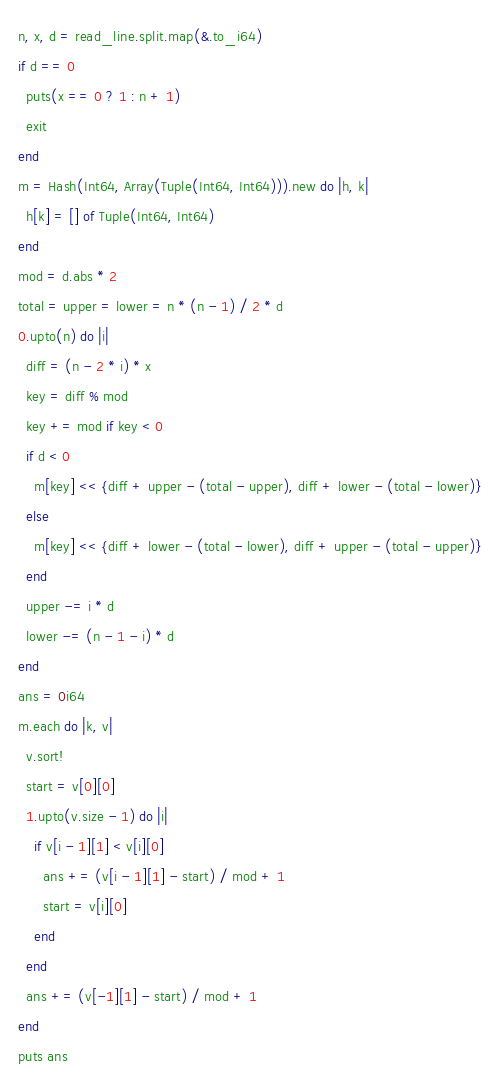<code> <loc_0><loc_0><loc_500><loc_500><_Crystal_>n, x, d = read_line.split.map(&.to_i64)
if d == 0
  puts(x == 0 ? 1 : n + 1)
  exit
end
m = Hash(Int64, Array(Tuple(Int64, Int64))).new do |h, k|
  h[k] = [] of Tuple(Int64, Int64)
end
mod = d.abs * 2
total = upper = lower = n * (n - 1) / 2 * d
0.upto(n) do |i|
  diff = (n - 2 * i) * x
  key = diff % mod
  key += mod if key < 0
  if d < 0
    m[key] << {diff + upper - (total - upper), diff + lower - (total - lower)}
  else
    m[key] << {diff + lower - (total - lower), diff + upper - (total - upper)}
  end
  upper -= i * d
  lower -= (n - 1 - i) * d
end
ans = 0i64
m.each do |k, v|
  v.sort!
  start = v[0][0]
  1.upto(v.size - 1) do |i|
    if v[i - 1][1] < v[i][0]
      ans += (v[i - 1][1] - start) / mod + 1
      start = v[i][0]
    end
  end
  ans += (v[-1][1] - start) / mod + 1
end
puts ans
</code> 